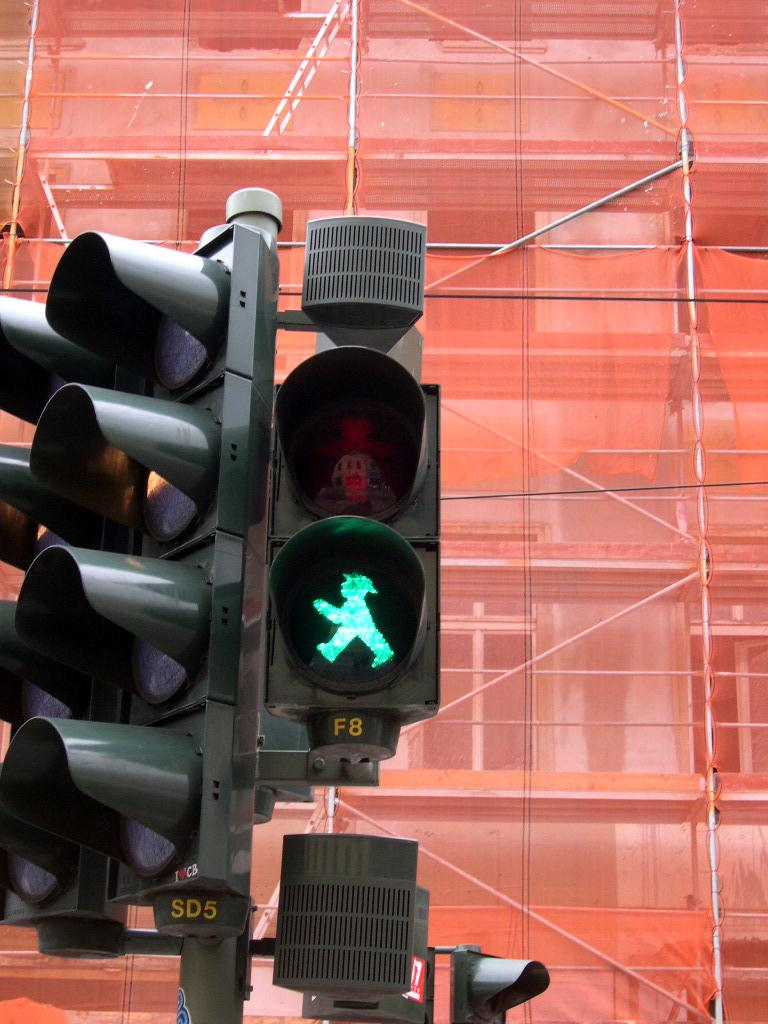Provide a one-sentence caption for the provided image. A pedestrian traffic light shows a little green person and the code F8 under it. 